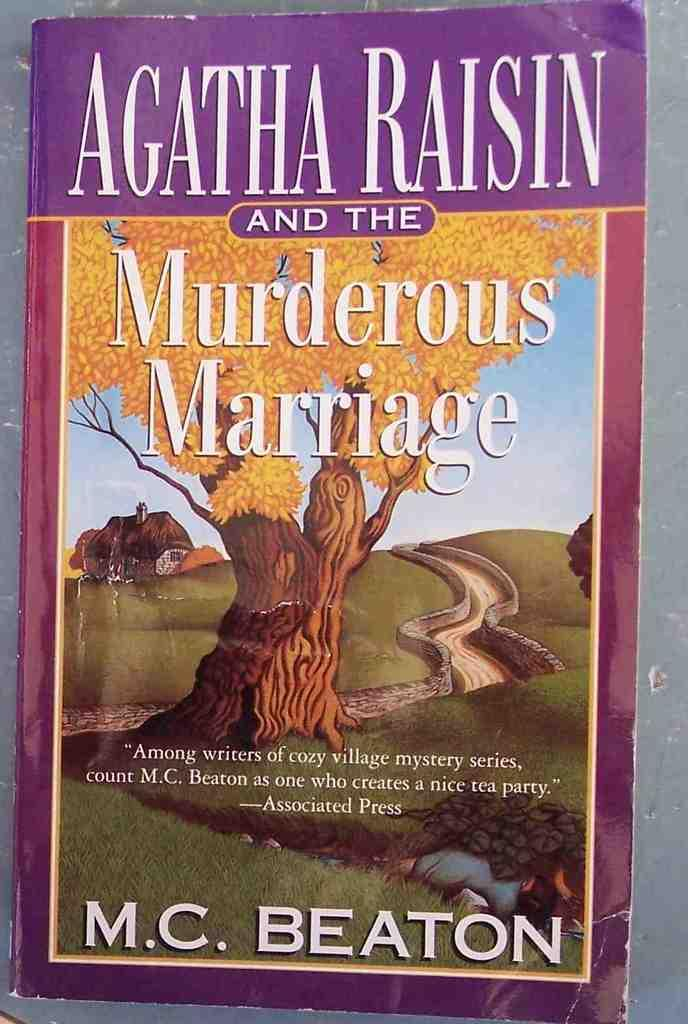<image>
Provide a brief description of the given image. A book by M.C. Beaton titled Agatha Raisin and the Murderous Marriage sits on a table 